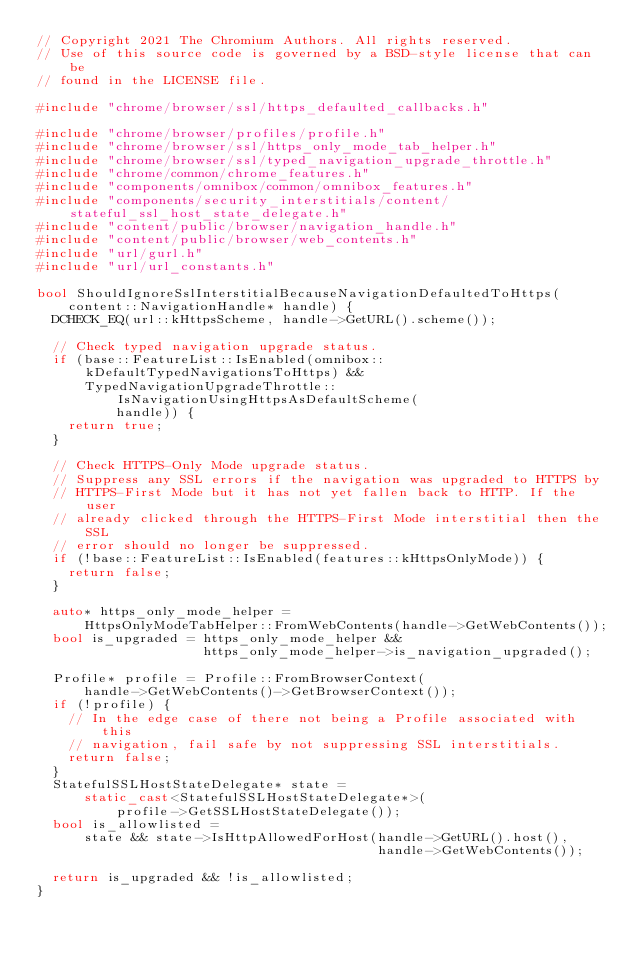Convert code to text. <code><loc_0><loc_0><loc_500><loc_500><_C++_>// Copyright 2021 The Chromium Authors. All rights reserved.
// Use of this source code is governed by a BSD-style license that can be
// found in the LICENSE file.

#include "chrome/browser/ssl/https_defaulted_callbacks.h"

#include "chrome/browser/profiles/profile.h"
#include "chrome/browser/ssl/https_only_mode_tab_helper.h"
#include "chrome/browser/ssl/typed_navigation_upgrade_throttle.h"
#include "chrome/common/chrome_features.h"
#include "components/omnibox/common/omnibox_features.h"
#include "components/security_interstitials/content/stateful_ssl_host_state_delegate.h"
#include "content/public/browser/navigation_handle.h"
#include "content/public/browser/web_contents.h"
#include "url/gurl.h"
#include "url/url_constants.h"

bool ShouldIgnoreSslInterstitialBecauseNavigationDefaultedToHttps(
    content::NavigationHandle* handle) {
  DCHECK_EQ(url::kHttpsScheme, handle->GetURL().scheme());

  // Check typed navigation upgrade status.
  if (base::FeatureList::IsEnabled(omnibox::kDefaultTypedNavigationsToHttps) &&
      TypedNavigationUpgradeThrottle::IsNavigationUsingHttpsAsDefaultScheme(
          handle)) {
    return true;
  }

  // Check HTTPS-Only Mode upgrade status.
  // Suppress any SSL errors if the navigation was upgraded to HTTPS by
  // HTTPS-First Mode but it has not yet fallen back to HTTP. If the user
  // already clicked through the HTTPS-First Mode interstitial then the SSL
  // error should no longer be suppressed.
  if (!base::FeatureList::IsEnabled(features::kHttpsOnlyMode)) {
    return false;
  }

  auto* https_only_mode_helper =
      HttpsOnlyModeTabHelper::FromWebContents(handle->GetWebContents());
  bool is_upgraded = https_only_mode_helper &&
                     https_only_mode_helper->is_navigation_upgraded();

  Profile* profile = Profile::FromBrowserContext(
      handle->GetWebContents()->GetBrowserContext());
  if (!profile) {
    // In the edge case of there not being a Profile associated with this
    // navigation, fail safe by not suppressing SSL interstitials.
    return false;
  }
  StatefulSSLHostStateDelegate* state =
      static_cast<StatefulSSLHostStateDelegate*>(
          profile->GetSSLHostStateDelegate());
  bool is_allowlisted =
      state && state->IsHttpAllowedForHost(handle->GetURL().host(),
                                           handle->GetWebContents());

  return is_upgraded && !is_allowlisted;
}
</code> 